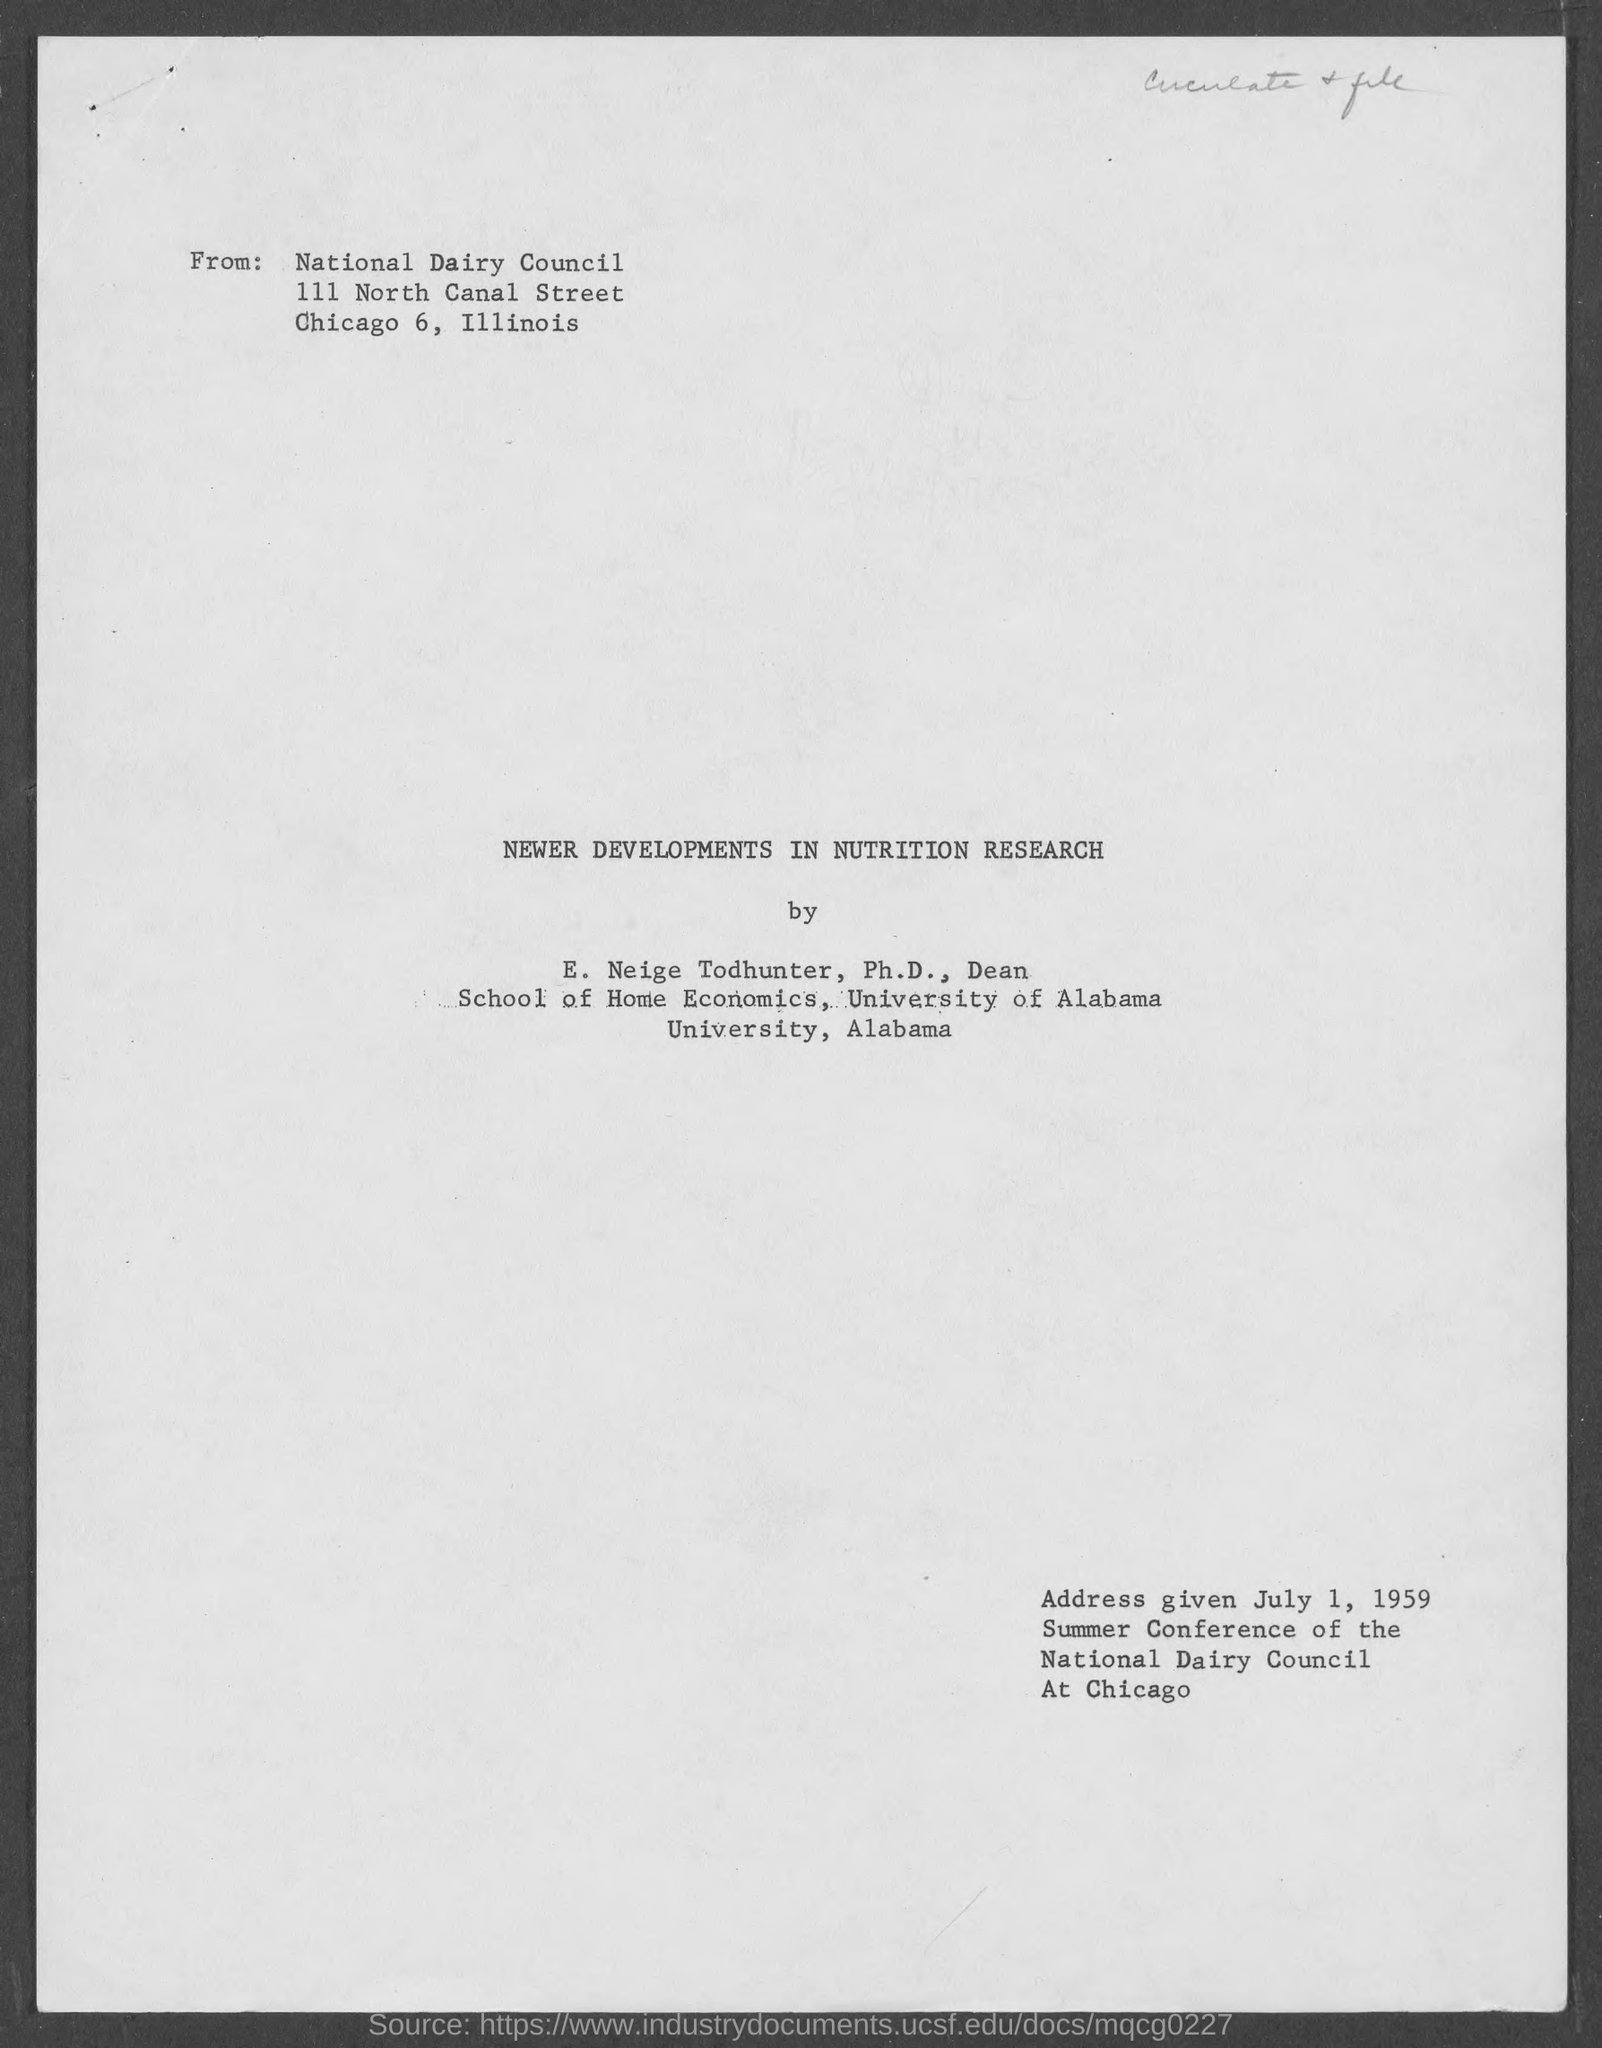Outline some significant characteristics in this image. The title of the given document is 'Newer Developments in Nutrition Research'. 